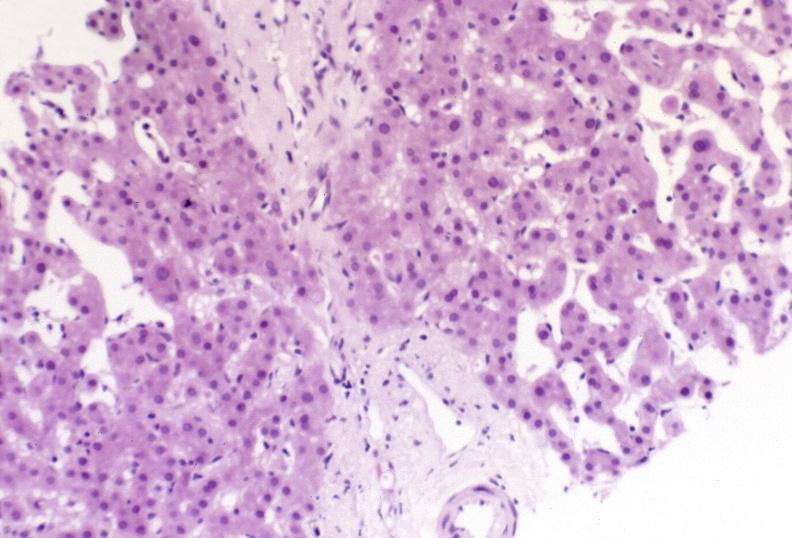does a bulge show ductopenia?
Answer the question using a single word or phrase. No 